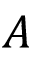Convert formula to latex. <formula><loc_0><loc_0><loc_500><loc_500>A</formula> 